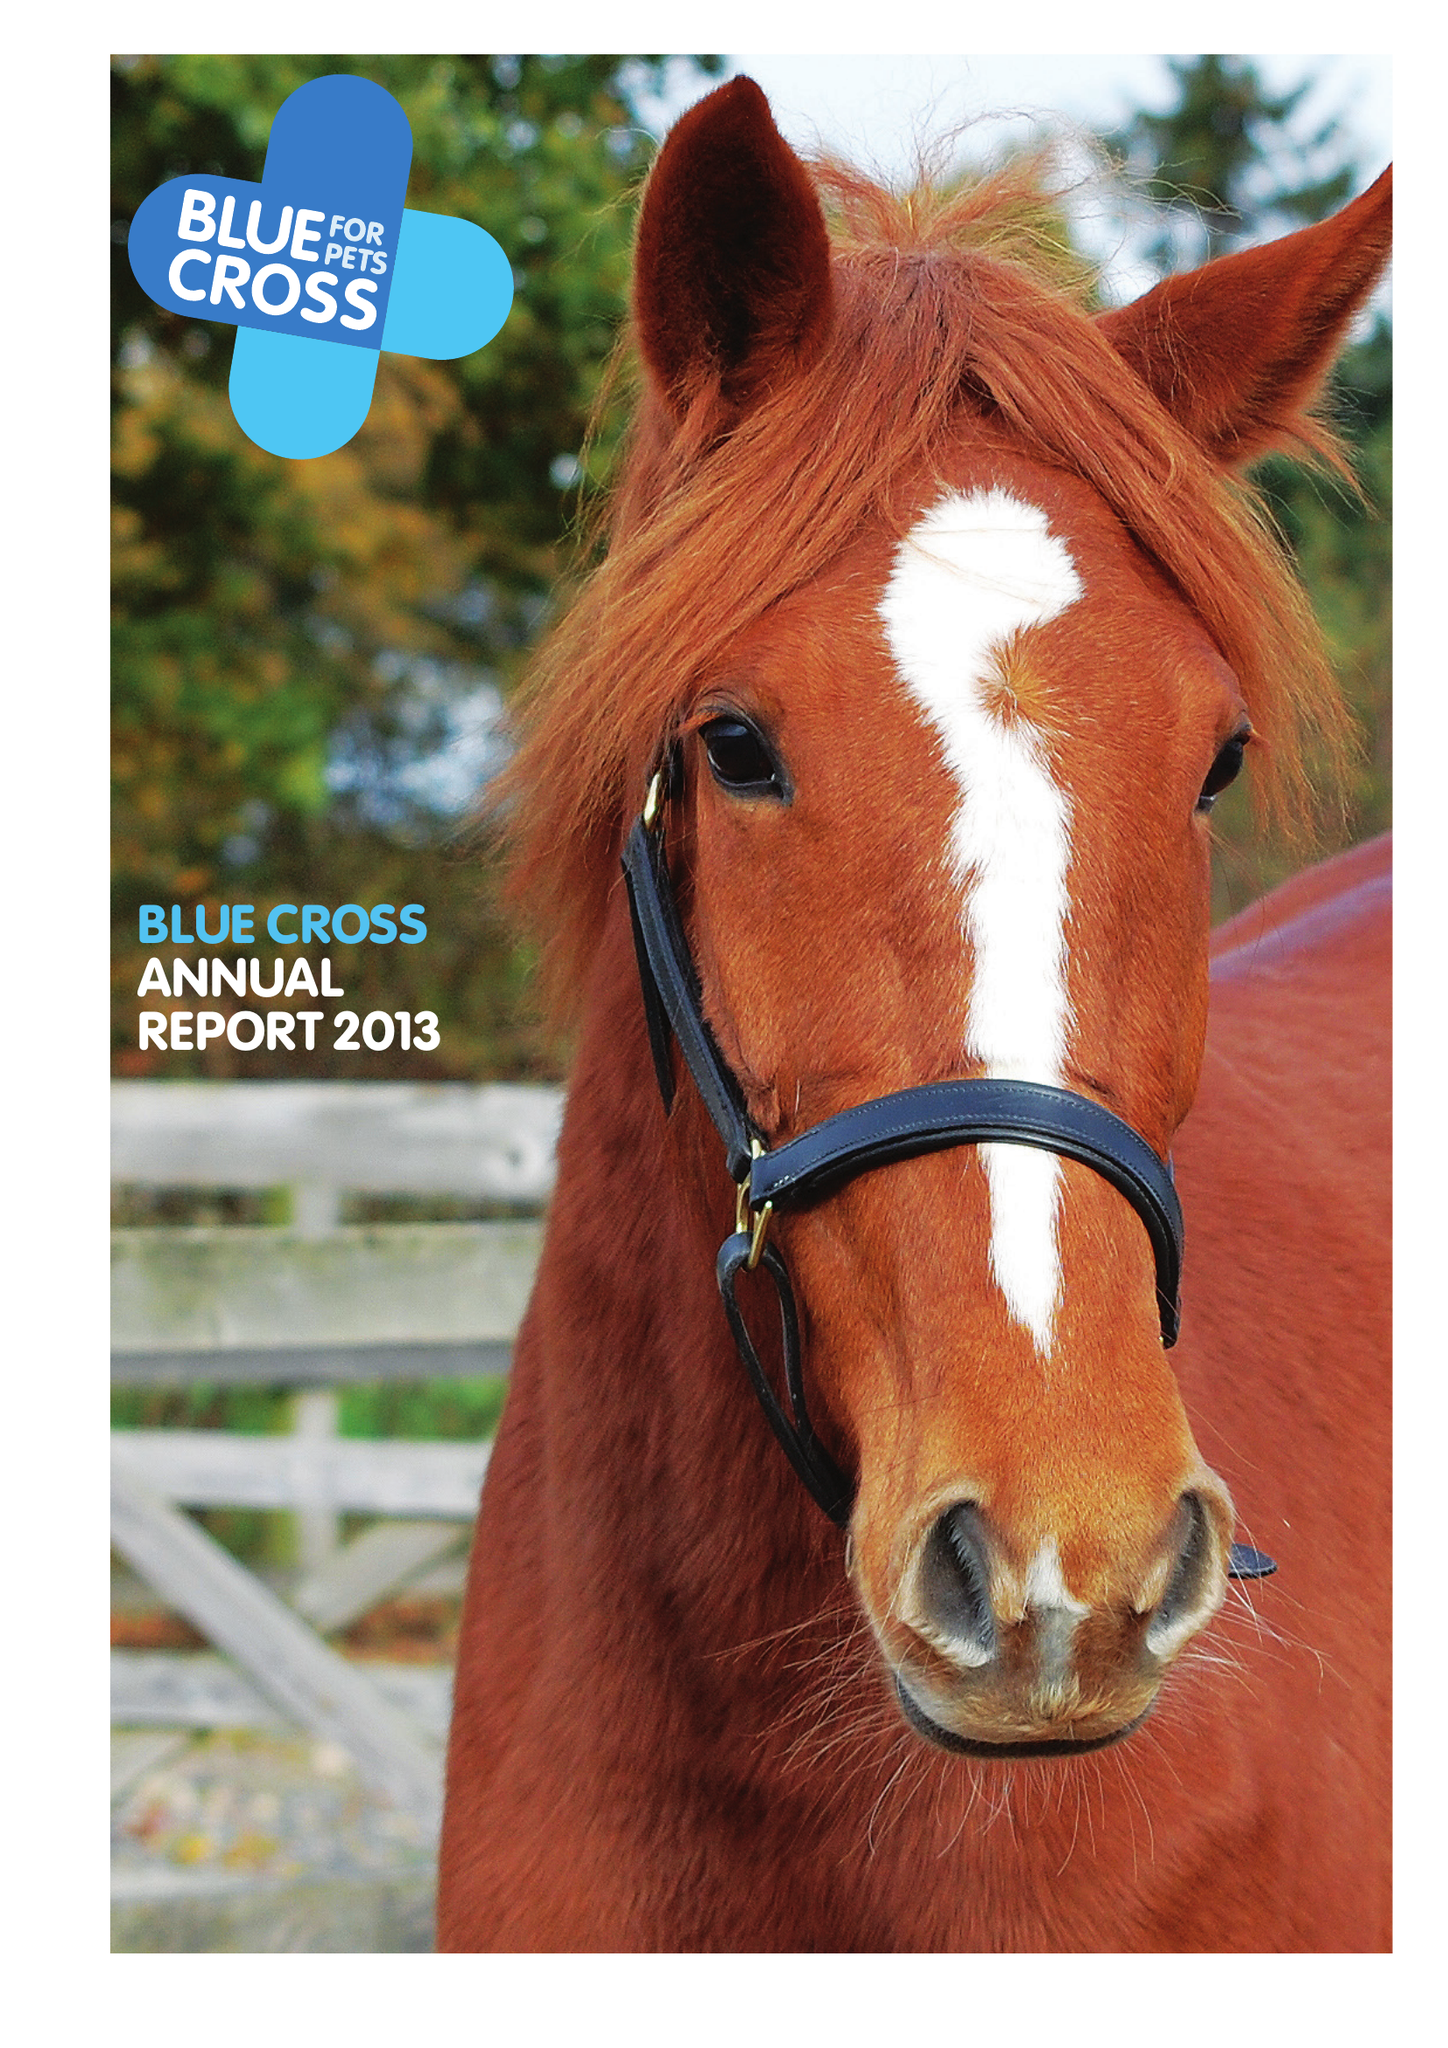What is the value for the address__street_line?
Answer the question using a single word or phrase. SHILTON ROAD 